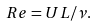<formula> <loc_0><loc_0><loc_500><loc_500>R e = U L / \nu .</formula> 